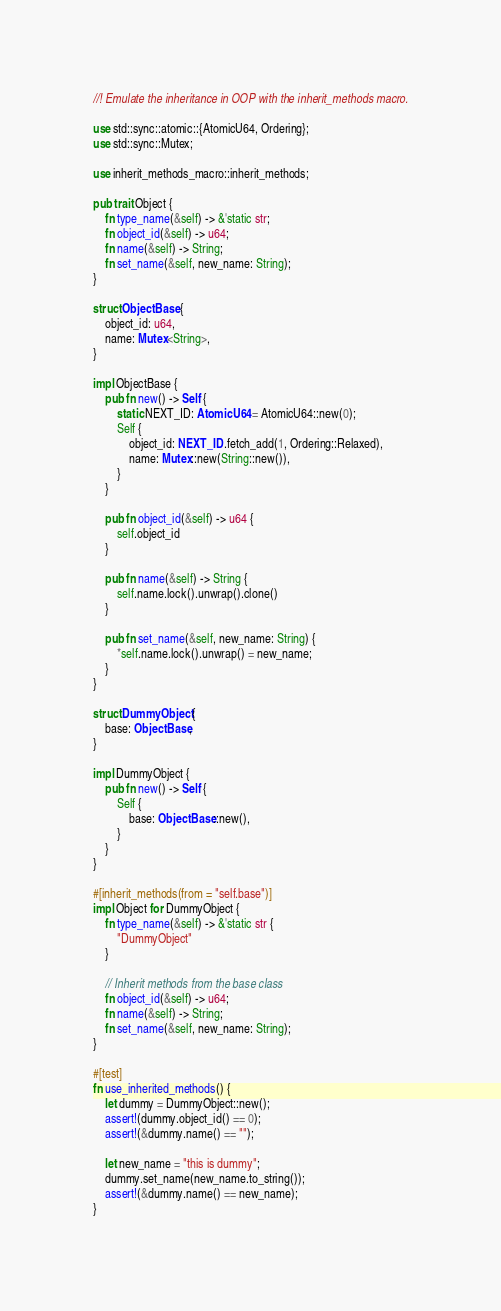<code> <loc_0><loc_0><loc_500><loc_500><_Rust_>//! Emulate the inheritance in OOP with the inherit_methods macro.

use std::sync::atomic::{AtomicU64, Ordering};
use std::sync::Mutex;

use inherit_methods_macro::inherit_methods;

pub trait Object {
    fn type_name(&self) -> &'static str;
    fn object_id(&self) -> u64;
    fn name(&self) -> String;
    fn set_name(&self, new_name: String);
}

struct ObjectBase {
    object_id: u64,
    name: Mutex<String>,
}

impl ObjectBase {
    pub fn new() -> Self {
        static NEXT_ID: AtomicU64 = AtomicU64::new(0);
        Self {
            object_id: NEXT_ID.fetch_add(1, Ordering::Relaxed),
            name: Mutex::new(String::new()),
        }
    }

    pub fn object_id(&self) -> u64 {
        self.object_id
    }

    pub fn name(&self) -> String {
        self.name.lock().unwrap().clone()
    }

    pub fn set_name(&self, new_name: String) {
        *self.name.lock().unwrap() = new_name;
    }
}

struct DummyObject {
    base: ObjectBase,
}

impl DummyObject {
    pub fn new() -> Self {
        Self {
            base: ObjectBase::new(),
        }
    }
}

#[inherit_methods(from = "self.base")]
impl Object for DummyObject {
    fn type_name(&self) -> &'static str {
        "DummyObject"
    }

    // Inherit methods from the base class
    fn object_id(&self) -> u64;
    fn name(&self) -> String;
    fn set_name(&self, new_name: String);
}

#[test]
fn use_inherited_methods() {
    let dummy = DummyObject::new();
    assert!(dummy.object_id() == 0);
    assert!(&dummy.name() == "");

    let new_name = "this is dummy";
    dummy.set_name(new_name.to_string());
    assert!(&dummy.name() == new_name);
}
</code> 